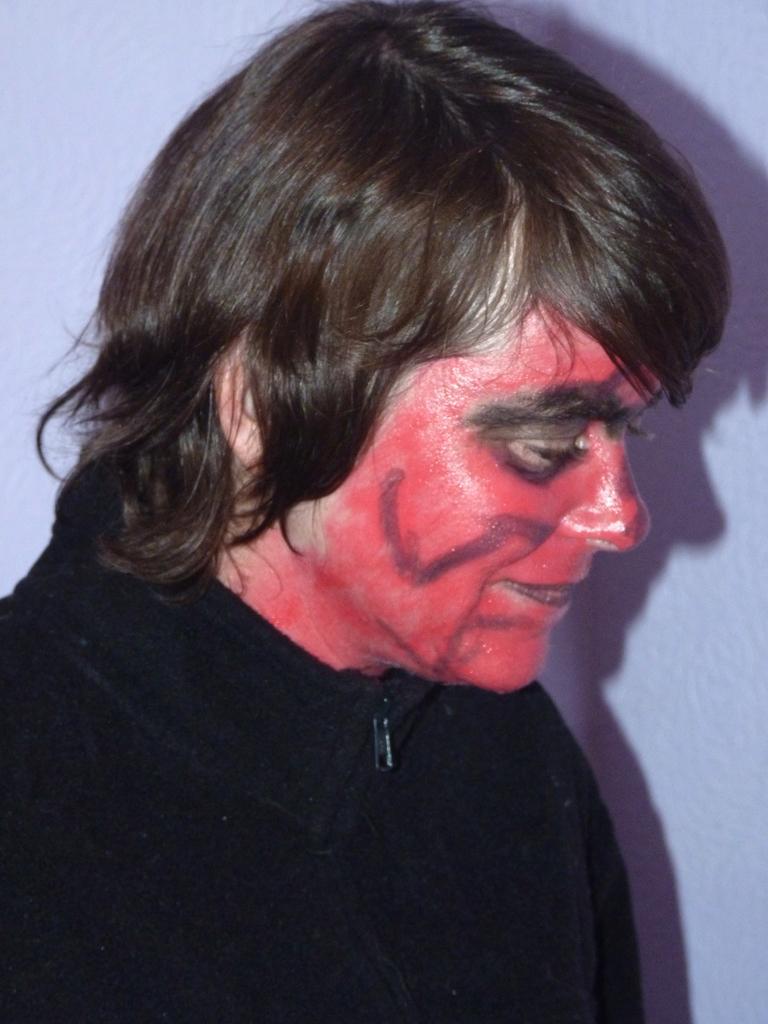Can you describe this image briefly? In this image, I can see a person smiling. This person wore a red color paint to the face. This is the wall. I can see the shadow of the man on the wall. 